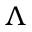Convert formula to latex. <formula><loc_0><loc_0><loc_500><loc_500>\Lambda</formula> 